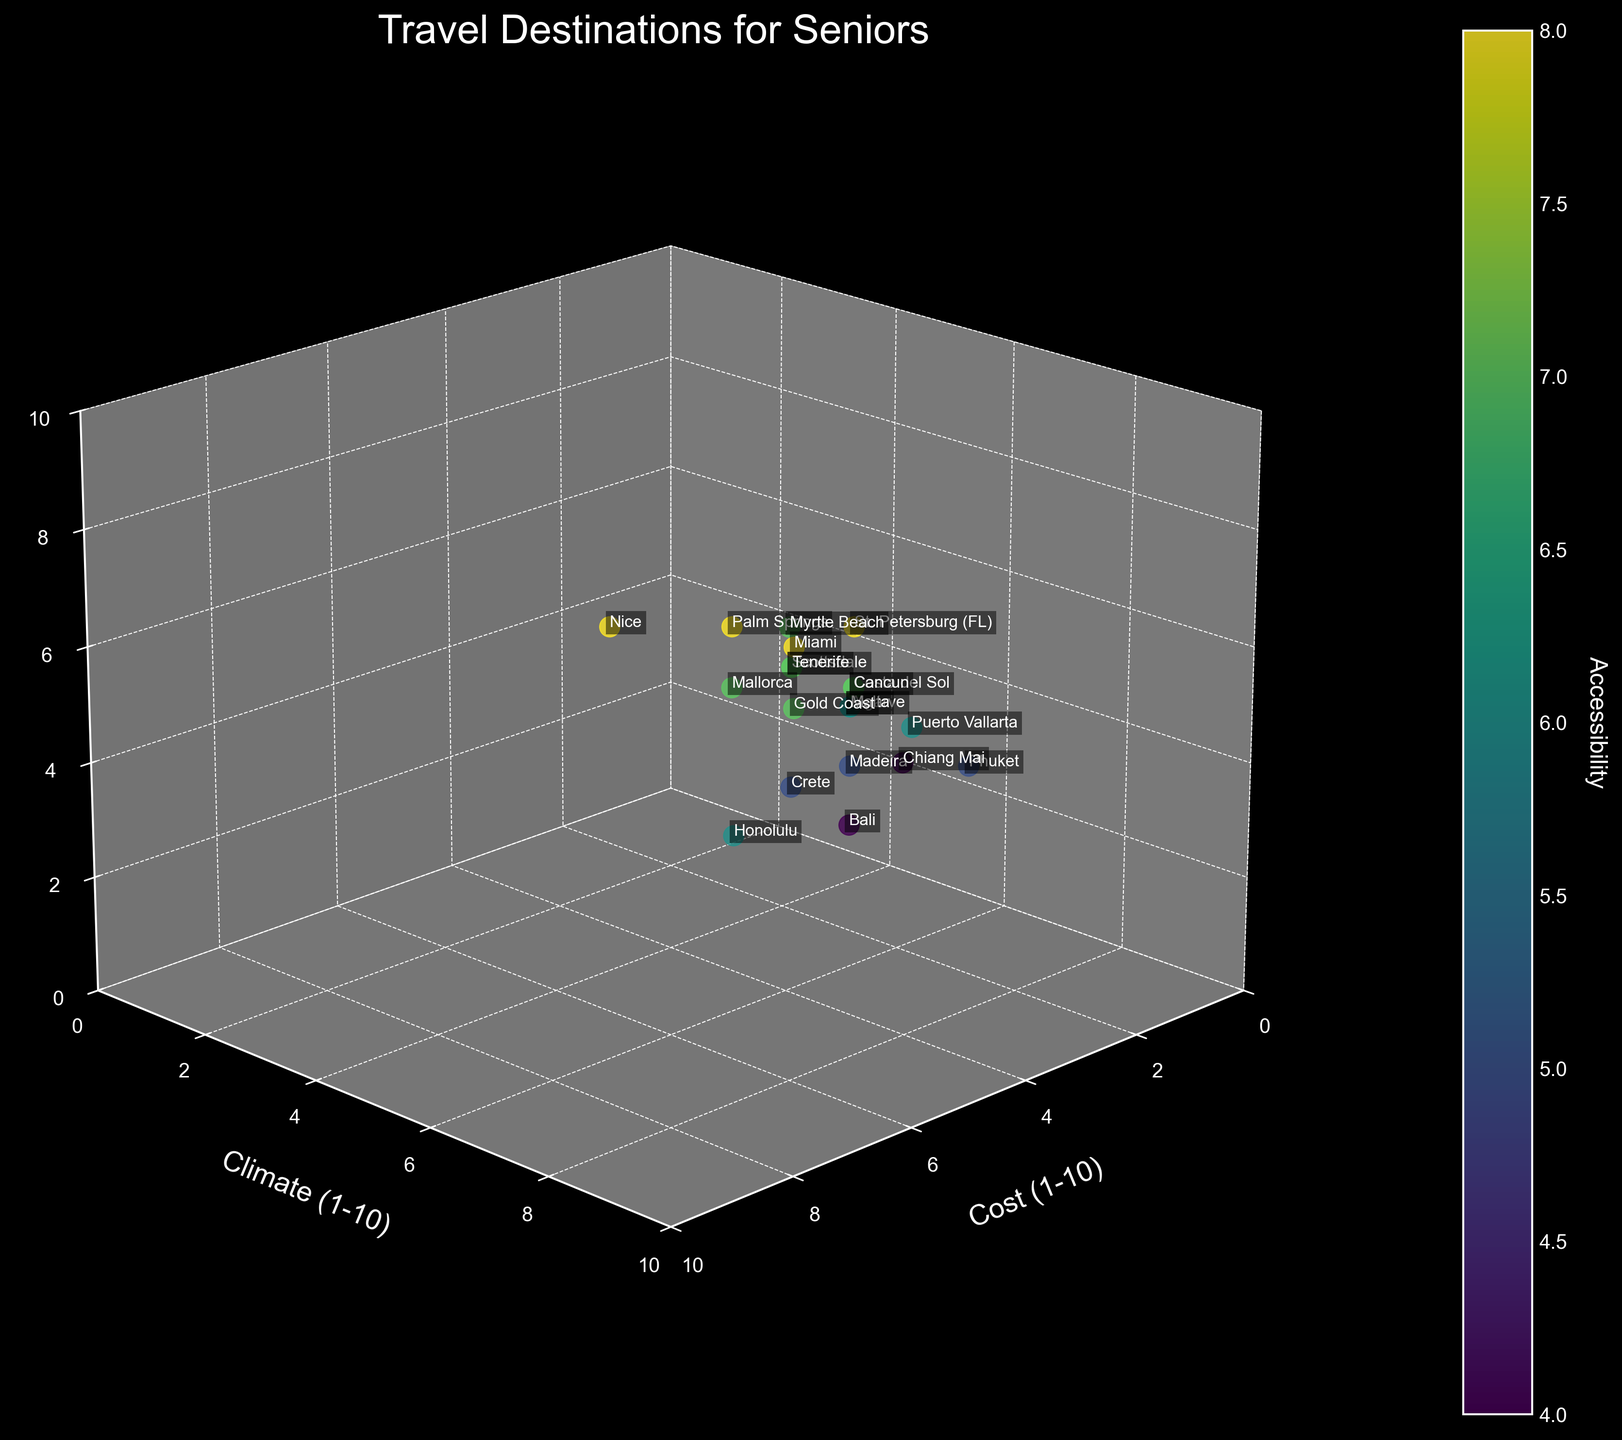What is the title of the figure? The title is located at the top center of the figure. It usually summarizes the main topic or purpose of the plot.
Answer: Travel Destinations for Seniors How many destinations have a cost rating of 5? Look at the axis labeled "Cost (1-10)" and count the data points that align with the value 5.
Answer: Five destinations Which destination has the highest cost rating? Look for the data point with the highest value on the "Cost (1-10)" axis, then check the corresponding label.
Answer: Honolulu What is the common climate rating for destinations with an accessibility rating of 8? Identify the points with an accessibility rating of 8 and observe their corresponding climate ratings.
Answer: 8 or 9 Which destinations have an accessibility rating less than 6 and what is their cost rating? Locate the points with accessibility values below 6 and read off their corresponding cost ratings.
Answer: Phuket (4), Bali (5), Chiang Mai (3), Crete (6), Madeira (5) Which destination has the highest climate rating and what is its accessibility rating? Find the point with the highest value on the "Climate (1-10)" axis and note its accessibility rating.
Answer: Honolulu; Accessibility rating is 6 Compare the climate and accessibility ratings for Miami and Scottsdale. Which one has a higher overall score? Check the climate and accessibility ratings for both Miami and Scottsdale, then sum the two values for each destination to compare.
Answer: Miami has a higher overall score (9+8=17 vs 8+7=15) What is the average cost rating of destinations with a climate rating of 8? Identify destinations with a climate rating of 8, sum their cost ratings, and divide by the number of those destinations.
Answer: (6+5+6+5+5+6+7) / 7 = 5.71 Does any destination have a cost rating equal to its accessibility rating? If so, which one(s)? Compare the cost and accessibility ratings for each destination to see if they match.
Answer: No destinations have matching cost and accessibility ratings Which destinations are plotted closest to each other in terms of cost, climate, and accessibility? Visually inspect the 3D scatter plot to find data points that are nearest to one another in all three dimensions.
Answer: Madeira and Bali 